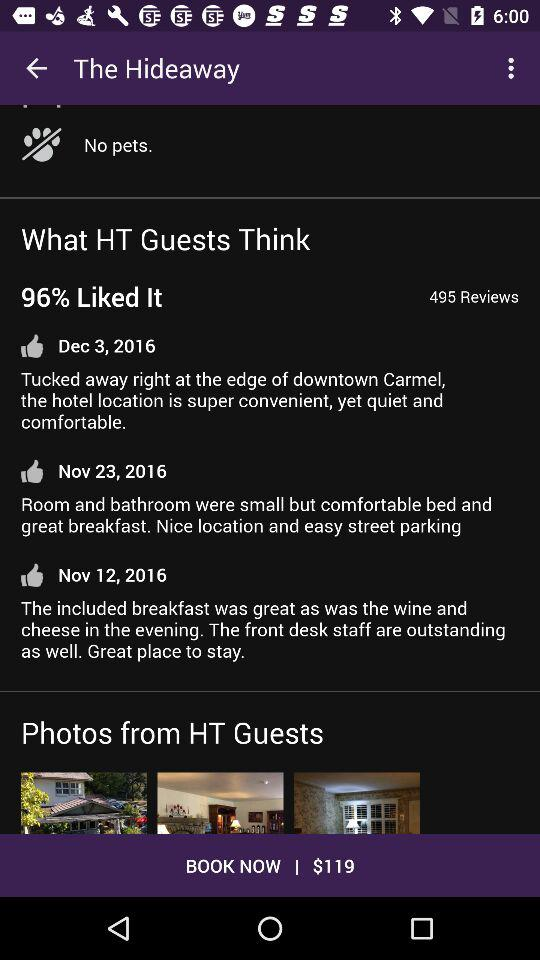What is the percentage of likes? The percentage of likes is 96. 